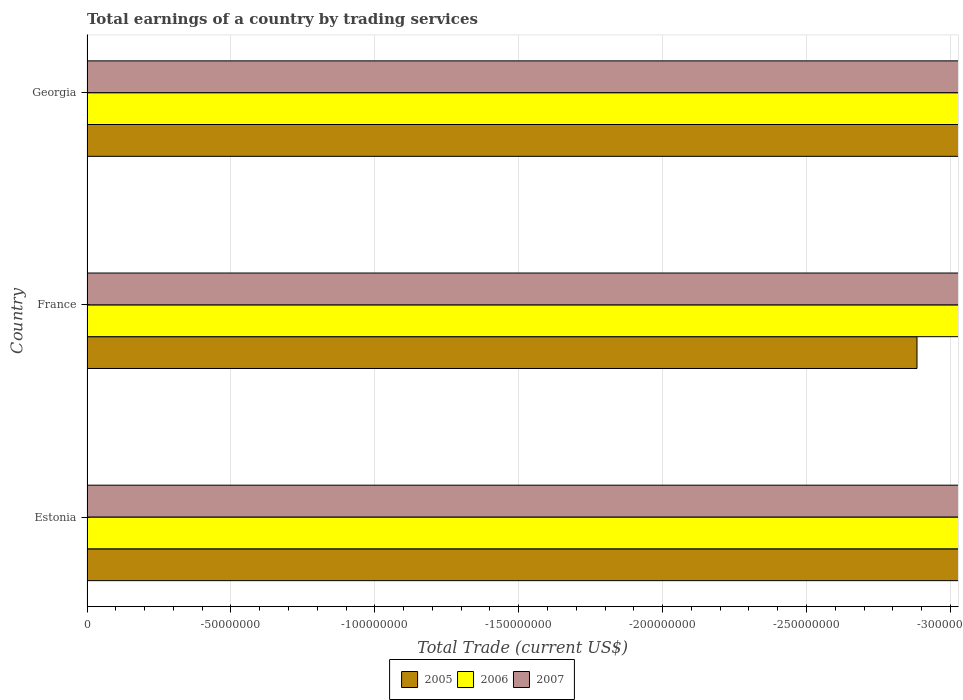How many different coloured bars are there?
Give a very brief answer. 0. How many bars are there on the 1st tick from the top?
Provide a succinct answer. 0. What is the label of the 3rd group of bars from the top?
Offer a very short reply. Estonia. In how many cases, is the number of bars for a given country not equal to the number of legend labels?
Provide a short and direct response. 3. What is the total earnings in 2006 in France?
Make the answer very short. 0. Across all countries, what is the minimum total earnings in 2007?
Offer a very short reply. 0. What is the total total earnings in 2007 in the graph?
Offer a very short reply. 0. What is the difference between the total earnings in 2007 in France and the total earnings in 2006 in Georgia?
Your answer should be very brief. 0. What is the average total earnings in 2007 per country?
Keep it short and to the point. 0. In how many countries, is the total earnings in 2005 greater than -220000000 US$?
Provide a succinct answer. 0. In how many countries, is the total earnings in 2007 greater than the average total earnings in 2007 taken over all countries?
Provide a succinct answer. 0. How many bars are there?
Make the answer very short. 0. Are all the bars in the graph horizontal?
Offer a terse response. Yes. What is the difference between two consecutive major ticks on the X-axis?
Keep it short and to the point. 5.00e+07. Does the graph contain any zero values?
Offer a terse response. Yes. Does the graph contain grids?
Your response must be concise. Yes. How many legend labels are there?
Offer a very short reply. 3. How are the legend labels stacked?
Your answer should be very brief. Horizontal. What is the title of the graph?
Provide a short and direct response. Total earnings of a country by trading services. Does "1985" appear as one of the legend labels in the graph?
Keep it short and to the point. No. What is the label or title of the X-axis?
Provide a succinct answer. Total Trade (current US$). What is the Total Trade (current US$) in 2005 in Estonia?
Provide a succinct answer. 0. What is the Total Trade (current US$) in 2007 in Estonia?
Make the answer very short. 0. What is the Total Trade (current US$) in 2005 in France?
Provide a succinct answer. 0. What is the Total Trade (current US$) of 2007 in France?
Your response must be concise. 0. What is the Total Trade (current US$) in 2005 in Georgia?
Ensure brevity in your answer.  0. What is the Total Trade (current US$) of 2007 in Georgia?
Your answer should be very brief. 0. What is the total Total Trade (current US$) of 2006 in the graph?
Make the answer very short. 0. What is the total Total Trade (current US$) in 2007 in the graph?
Offer a terse response. 0. What is the average Total Trade (current US$) in 2006 per country?
Provide a short and direct response. 0. 